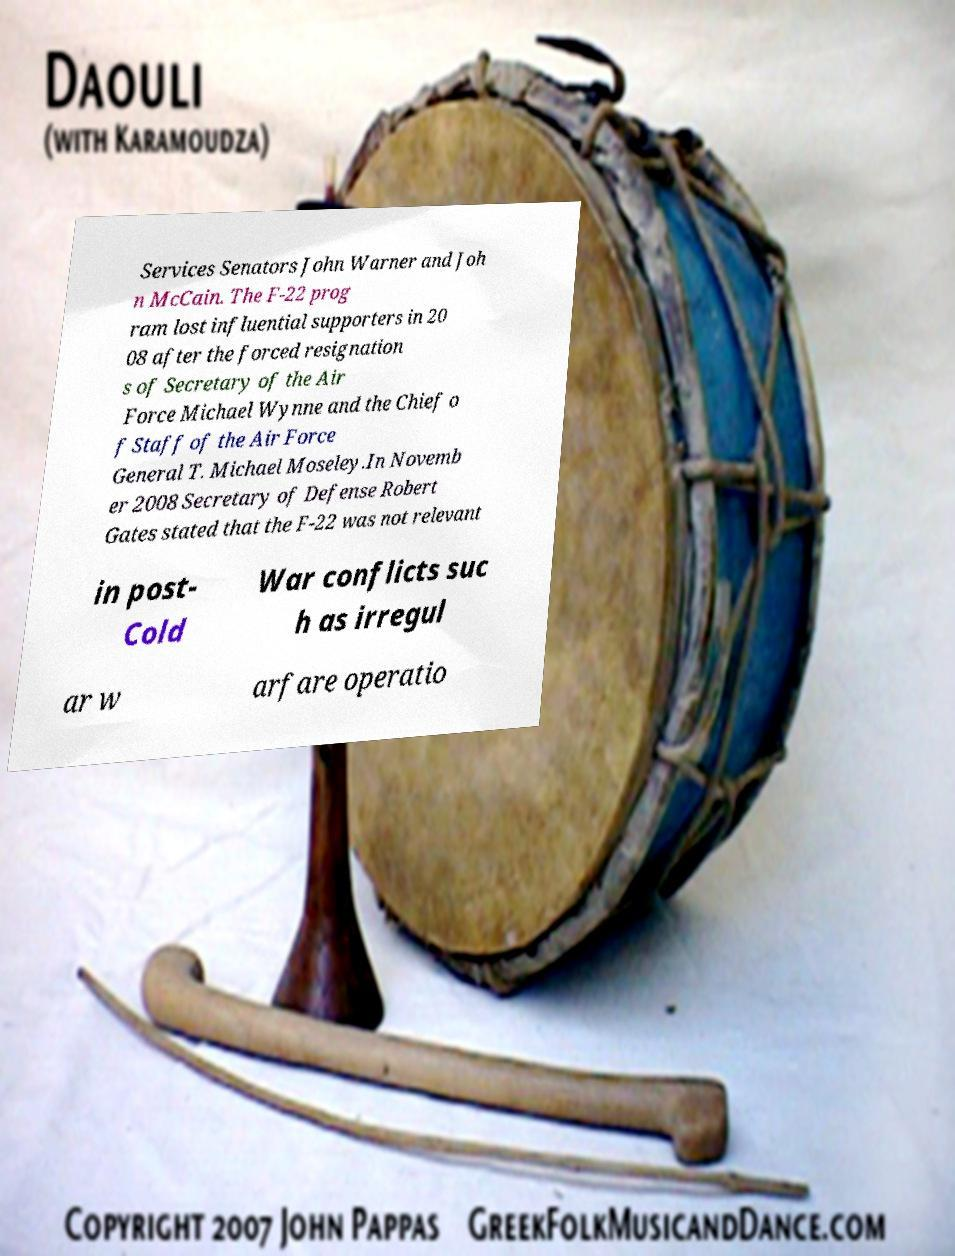Can you read and provide the text displayed in the image?This photo seems to have some interesting text. Can you extract and type it out for me? Services Senators John Warner and Joh n McCain. The F-22 prog ram lost influential supporters in 20 08 after the forced resignation s of Secretary of the Air Force Michael Wynne and the Chief o f Staff of the Air Force General T. Michael Moseley.In Novemb er 2008 Secretary of Defense Robert Gates stated that the F-22 was not relevant in post- Cold War conflicts suc h as irregul ar w arfare operatio 